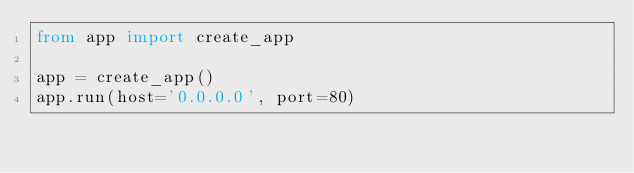Convert code to text. <code><loc_0><loc_0><loc_500><loc_500><_Python_>from app import create_app

app = create_app()
app.run(host='0.0.0.0', port=80)
</code> 